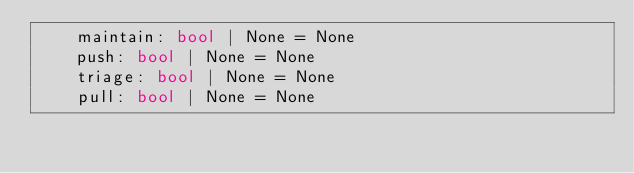Convert code to text. <code><loc_0><loc_0><loc_500><loc_500><_Python_>    maintain: bool | None = None
    push: bool | None = None
    triage: bool | None = None
    pull: bool | None = None
</code> 